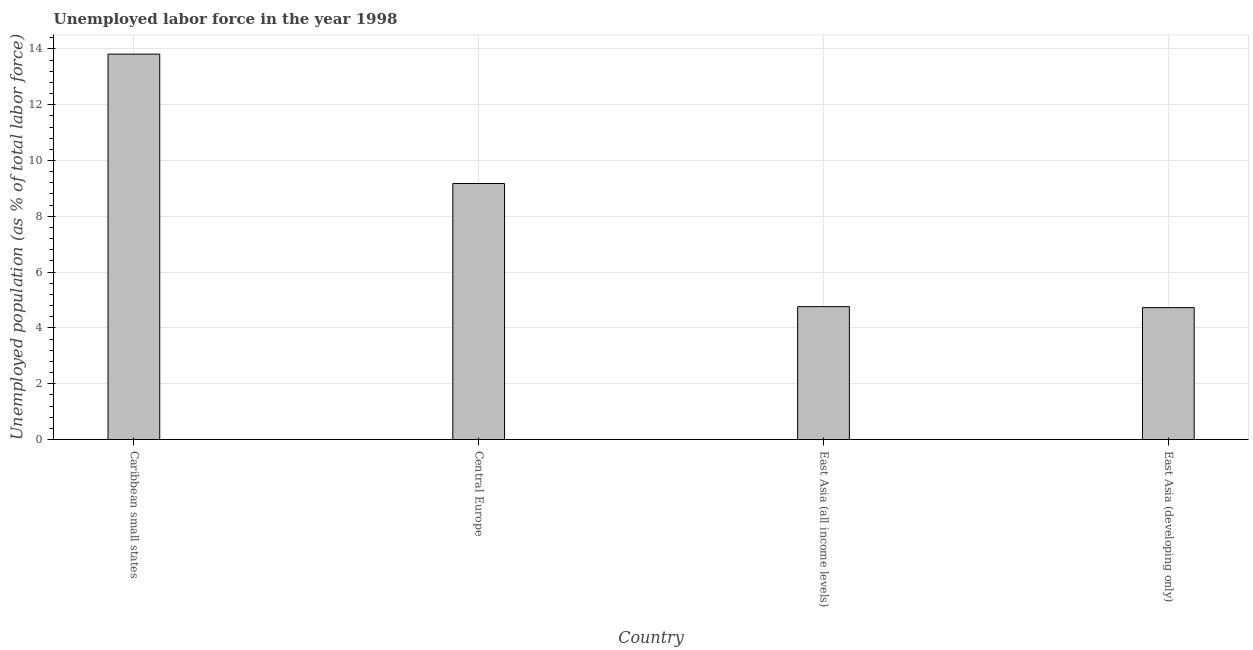Does the graph contain any zero values?
Offer a terse response. No. What is the title of the graph?
Provide a short and direct response. Unemployed labor force in the year 1998. What is the label or title of the X-axis?
Provide a short and direct response. Country. What is the label or title of the Y-axis?
Offer a very short reply. Unemployed population (as % of total labor force). What is the total unemployed population in Caribbean small states?
Make the answer very short. 13.81. Across all countries, what is the maximum total unemployed population?
Make the answer very short. 13.81. Across all countries, what is the minimum total unemployed population?
Keep it short and to the point. 4.73. In which country was the total unemployed population maximum?
Make the answer very short. Caribbean small states. In which country was the total unemployed population minimum?
Ensure brevity in your answer.  East Asia (developing only). What is the sum of the total unemployed population?
Provide a succinct answer. 32.48. What is the difference between the total unemployed population in Caribbean small states and East Asia (developing only)?
Give a very brief answer. 9.09. What is the average total unemployed population per country?
Give a very brief answer. 8.12. What is the median total unemployed population?
Provide a succinct answer. 6.97. What is the ratio of the total unemployed population in Central Europe to that in East Asia (developing only)?
Your response must be concise. 1.94. What is the difference between the highest and the second highest total unemployed population?
Provide a succinct answer. 4.64. What is the difference between the highest and the lowest total unemployed population?
Your answer should be compact. 9.08. In how many countries, is the total unemployed population greater than the average total unemployed population taken over all countries?
Your response must be concise. 2. How many countries are there in the graph?
Provide a short and direct response. 4. What is the difference between two consecutive major ticks on the Y-axis?
Keep it short and to the point. 2. Are the values on the major ticks of Y-axis written in scientific E-notation?
Ensure brevity in your answer.  No. What is the Unemployed population (as % of total labor force) in Caribbean small states?
Offer a very short reply. 13.81. What is the Unemployed population (as % of total labor force) of Central Europe?
Provide a short and direct response. 9.18. What is the Unemployed population (as % of total labor force) in East Asia (all income levels)?
Your answer should be compact. 4.76. What is the Unemployed population (as % of total labor force) of East Asia (developing only)?
Make the answer very short. 4.73. What is the difference between the Unemployed population (as % of total labor force) in Caribbean small states and Central Europe?
Your answer should be compact. 4.64. What is the difference between the Unemployed population (as % of total labor force) in Caribbean small states and East Asia (all income levels)?
Provide a short and direct response. 9.05. What is the difference between the Unemployed population (as % of total labor force) in Caribbean small states and East Asia (developing only)?
Make the answer very short. 9.08. What is the difference between the Unemployed population (as % of total labor force) in Central Europe and East Asia (all income levels)?
Provide a succinct answer. 4.41. What is the difference between the Unemployed population (as % of total labor force) in Central Europe and East Asia (developing only)?
Your answer should be compact. 4.45. What is the difference between the Unemployed population (as % of total labor force) in East Asia (all income levels) and East Asia (developing only)?
Offer a very short reply. 0.04. What is the ratio of the Unemployed population (as % of total labor force) in Caribbean small states to that in Central Europe?
Provide a short and direct response. 1.5. What is the ratio of the Unemployed population (as % of total labor force) in Caribbean small states to that in East Asia (developing only)?
Provide a short and direct response. 2.92. What is the ratio of the Unemployed population (as % of total labor force) in Central Europe to that in East Asia (all income levels)?
Provide a succinct answer. 1.93. What is the ratio of the Unemployed population (as % of total labor force) in Central Europe to that in East Asia (developing only)?
Make the answer very short. 1.94. 